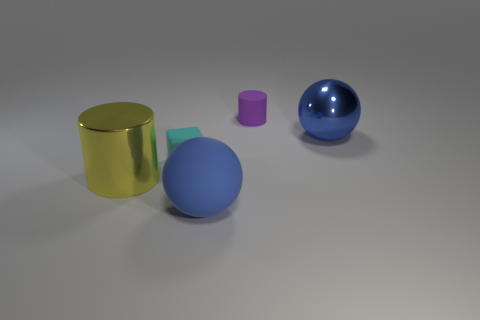Add 4 small cyan things. How many objects exist? 9 Subtract all cylinders. How many objects are left? 3 Add 2 small rubber cylinders. How many small rubber cylinders exist? 3 Subtract 0 cyan cylinders. How many objects are left? 5 Subtract all cyan objects. Subtract all blue metal objects. How many objects are left? 3 Add 1 big yellow shiny objects. How many big yellow shiny objects are left? 2 